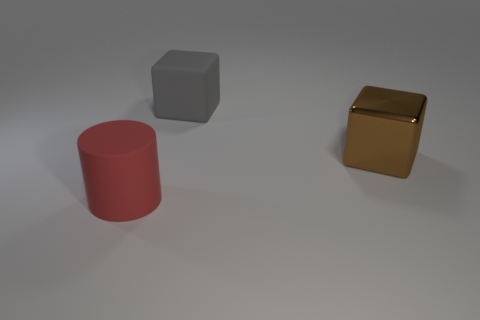What material is the other object that is the same shape as the brown thing?
Give a very brief answer. Rubber. There is a cube that is behind the big thing that is to the right of the rubber block; are there any cylinders that are to the right of it?
Offer a very short reply. No. Is the shape of the red thing the same as the large thing to the right of the matte block?
Ensure brevity in your answer.  No. Is there any other thing of the same color as the metal cube?
Your response must be concise. No. Do the big matte thing that is behind the big red rubber thing and the rubber object on the left side of the large gray object have the same color?
Your answer should be very brief. No. Are there any large gray cubes?
Give a very brief answer. Yes. Are there any other brown blocks that have the same material as the large brown block?
Give a very brief answer. No. Is there any other thing that is made of the same material as the large brown object?
Offer a very short reply. No. The metallic thing has what color?
Your response must be concise. Brown. There is a metallic thing that is the same size as the red matte thing; what color is it?
Provide a succinct answer. Brown. 